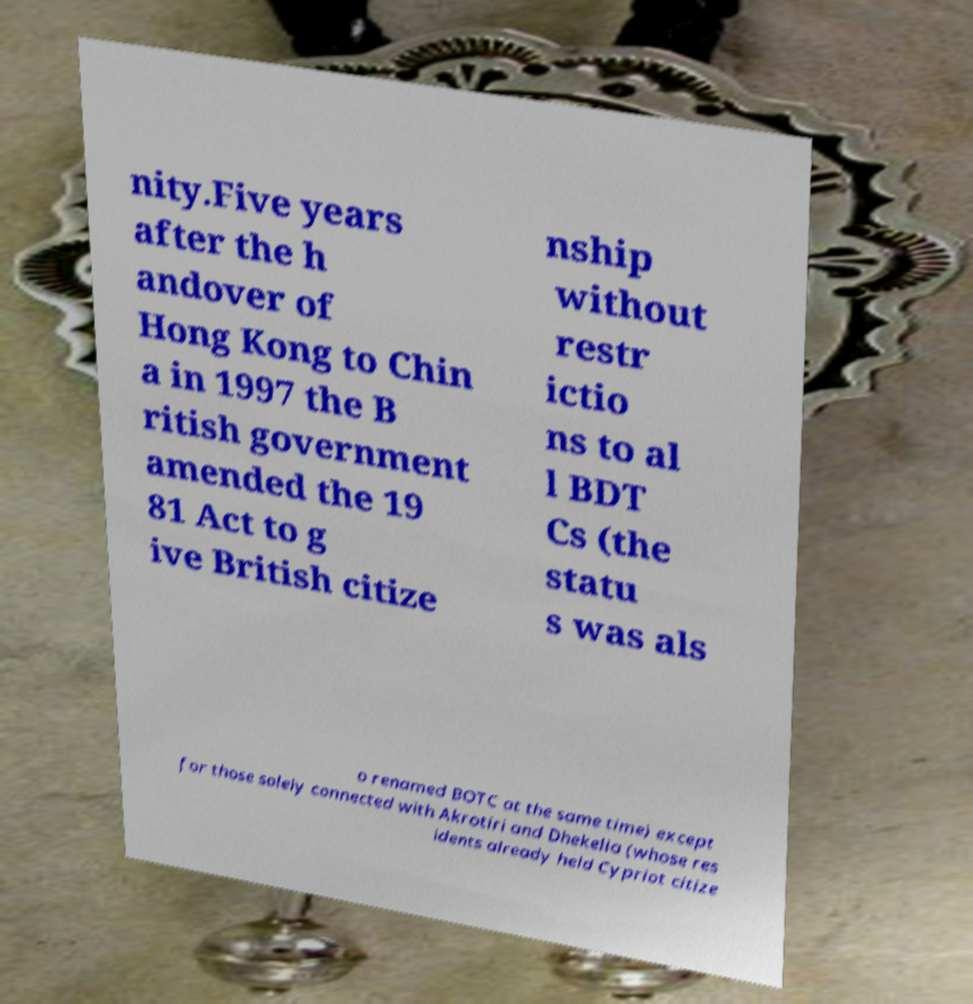There's text embedded in this image that I need extracted. Can you transcribe it verbatim? nity.Five years after the h andover of Hong Kong to Chin a in 1997 the B ritish government amended the 19 81 Act to g ive British citize nship without restr ictio ns to al l BDT Cs (the statu s was als o renamed BOTC at the same time) except for those solely connected with Akrotiri and Dhekelia (whose res idents already held Cypriot citize 